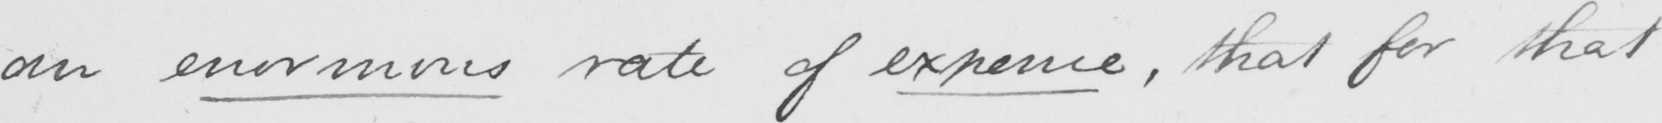What does this handwritten line say? an enormous rate of expence , that for that 